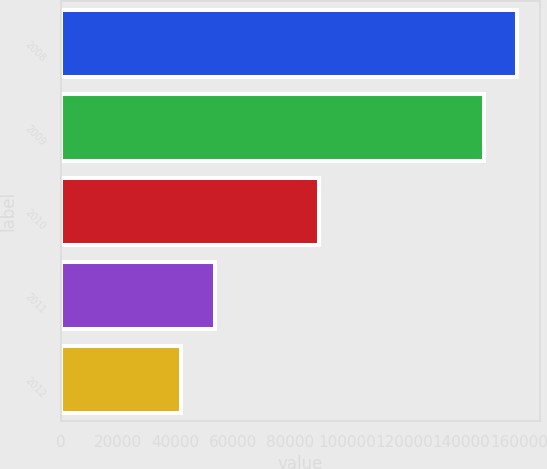Convert chart to OTSL. <chart><loc_0><loc_0><loc_500><loc_500><bar_chart><fcel>2008<fcel>2009<fcel>2010<fcel>2011<fcel>2012<nl><fcel>159513<fcel>147906<fcel>90215<fcel>53676.8<fcel>42070<nl></chart> 